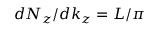Convert formula to latex. <formula><loc_0><loc_0><loc_500><loc_500>d N _ { z } / d k _ { z } = L / \pi</formula> 